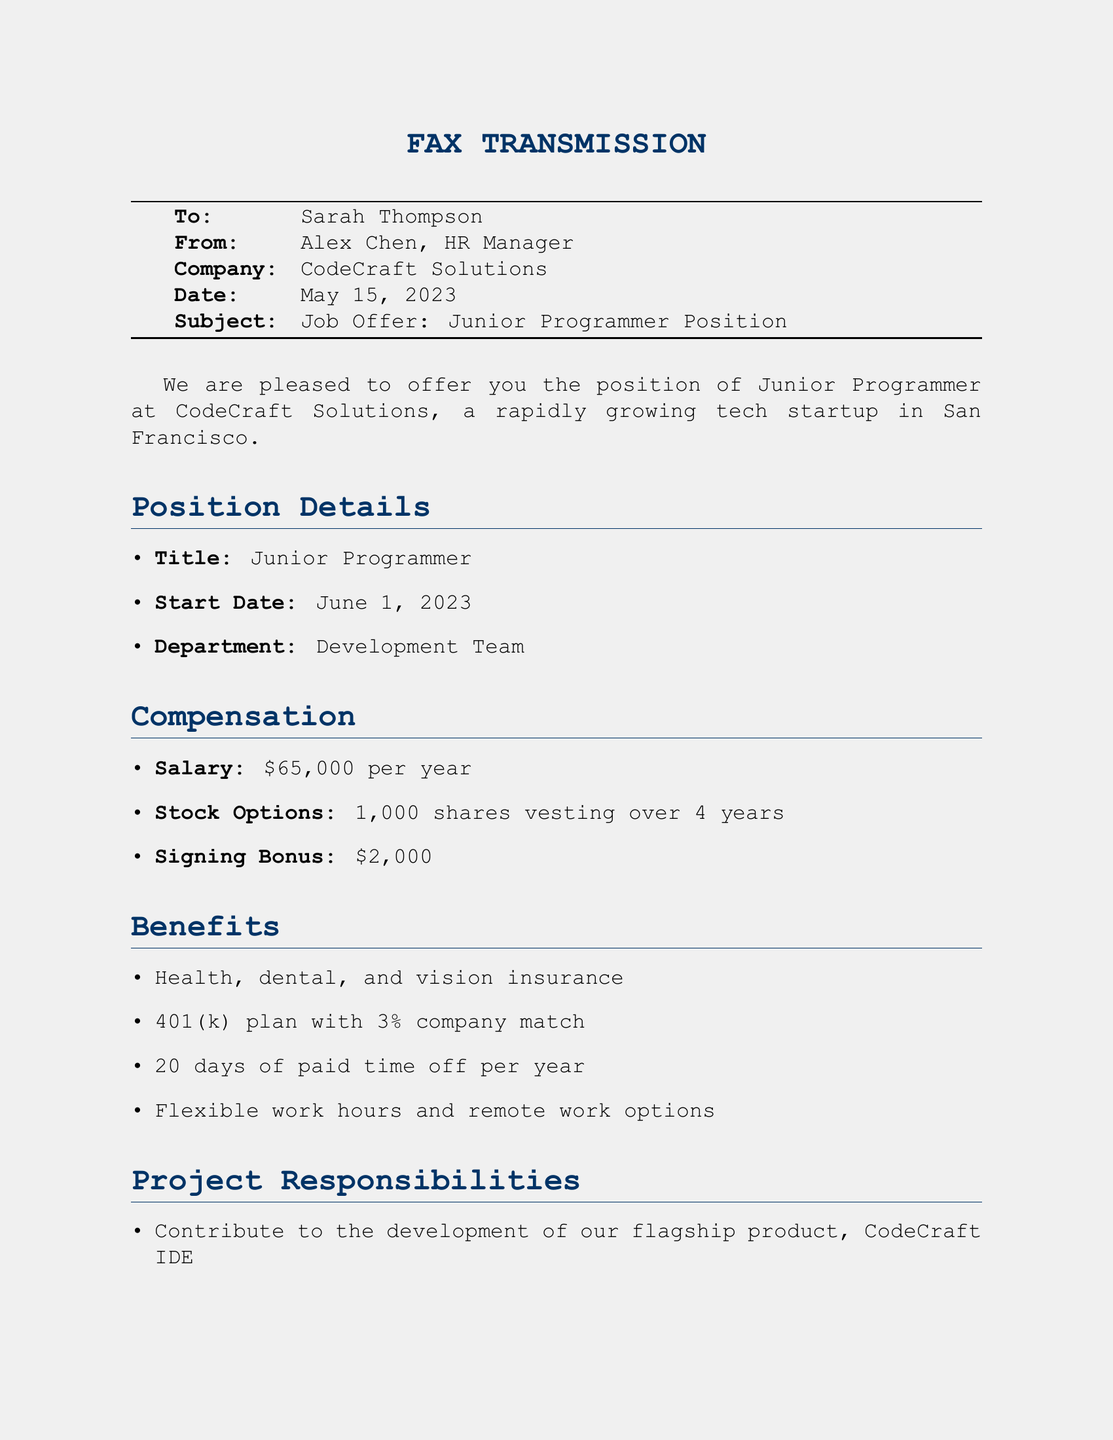What is the name of the recipient? The recipient of the fax is mentioned at the top as Sarah Thompson.
Answer: Sarah Thompson What is the salary offered for the position? The document lists the salary under the compensation section as twenty thousand.
Answer: $65,000 When is the start date for the Junior Programmer position? The start date is specified in the position details section of the fax.
Answer: June 1, 2023 How many days of paid time off are provided per year? The benefits section includes information on paid time off, stating twenty days.
Answer: 20 days What is the signing bonus amount? The signing bonus is detailed in the compensation section of the fax as a monetary value.
Answer: $2,000 Who is the sender of this fax? The sender is mentioned in the header of the document as Alex Chen.
Answer: Alex Chen What department will the new hire work in? The department is specified in the position details section of the document.
Answer: Development Team How many shares of stock options are offered? The stock options are detailed in the compensation section as a specific number of shares.
Answer: 1,000 shares What is one of the learning opportunities mentioned in the document? The document lists various learning opportunities available, one of which is external education.
Answer: Mentorship from experienced programmers 